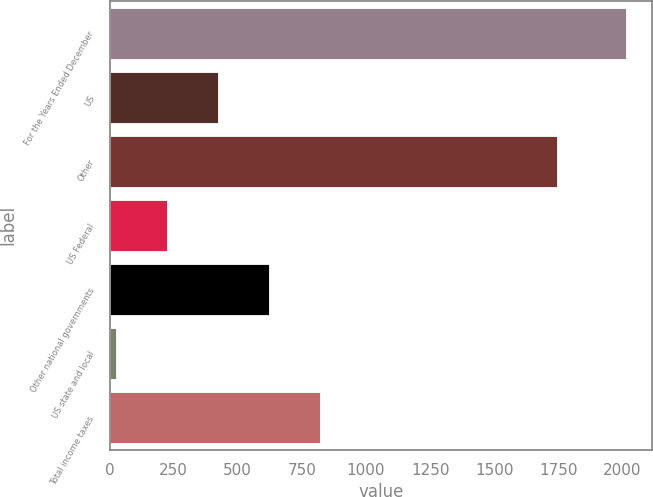Convert chart. <chart><loc_0><loc_0><loc_500><loc_500><bar_chart><fcel>For the Years Ended December<fcel>US<fcel>Other<fcel>US Federal<fcel>Other national governments<fcel>US state and local<fcel>Total income taxes<nl><fcel>2014<fcel>423.6<fcel>1744<fcel>224.8<fcel>622.4<fcel>26<fcel>821.2<nl></chart> 